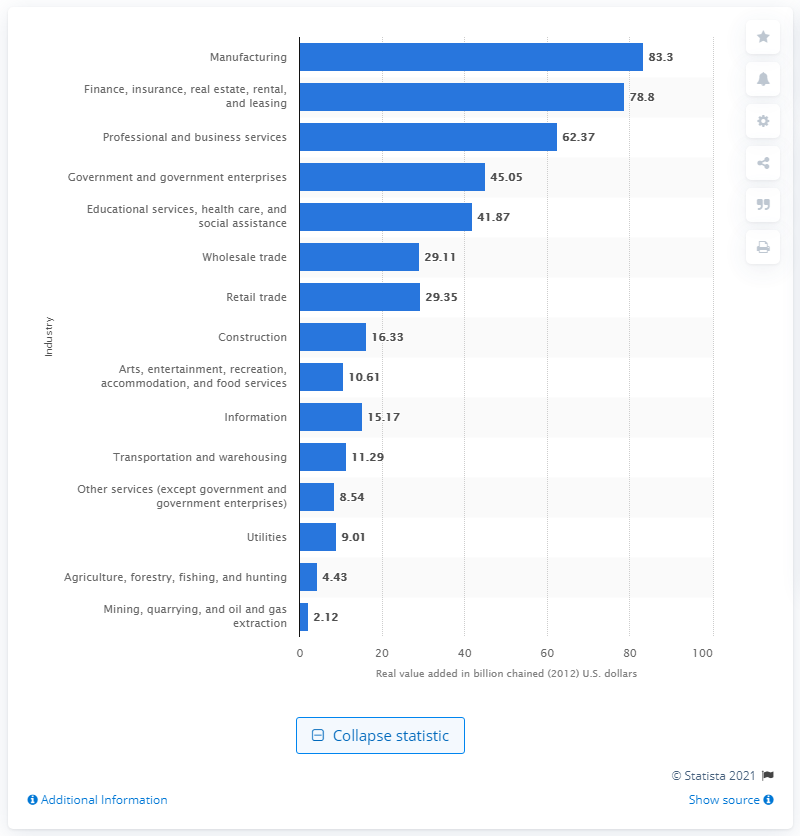Indicate a few pertinent items in this graphic. In 2012, the construction industry contributed a significant amount to the state's Gross Domestic Product (GDP) in Michigan, with a value of 16.33. 